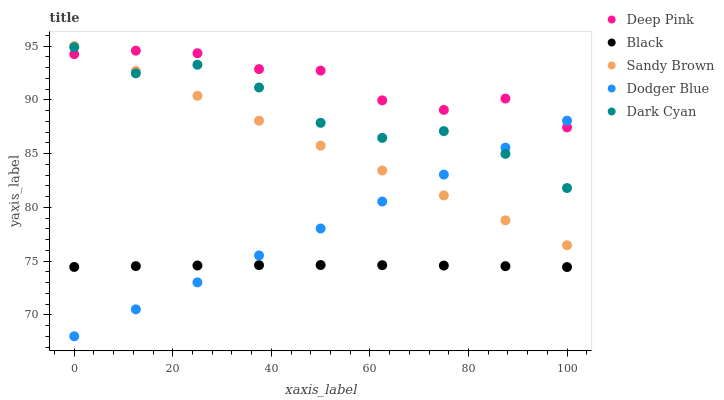Does Black have the minimum area under the curve?
Answer yes or no. Yes. Does Deep Pink have the maximum area under the curve?
Answer yes or no. Yes. Does Sandy Brown have the minimum area under the curve?
Answer yes or no. No. Does Sandy Brown have the maximum area under the curve?
Answer yes or no. No. Is Dodger Blue the smoothest?
Answer yes or no. Yes. Is Dark Cyan the roughest?
Answer yes or no. Yes. Is Sandy Brown the smoothest?
Answer yes or no. No. Is Sandy Brown the roughest?
Answer yes or no. No. Does Dodger Blue have the lowest value?
Answer yes or no. Yes. Does Sandy Brown have the lowest value?
Answer yes or no. No. Does Sandy Brown have the highest value?
Answer yes or no. Yes. Does Deep Pink have the highest value?
Answer yes or no. No. Is Black less than Sandy Brown?
Answer yes or no. Yes. Is Sandy Brown greater than Black?
Answer yes or no. Yes. Does Dark Cyan intersect Deep Pink?
Answer yes or no. Yes. Is Dark Cyan less than Deep Pink?
Answer yes or no. No. Is Dark Cyan greater than Deep Pink?
Answer yes or no. No. Does Black intersect Sandy Brown?
Answer yes or no. No. 